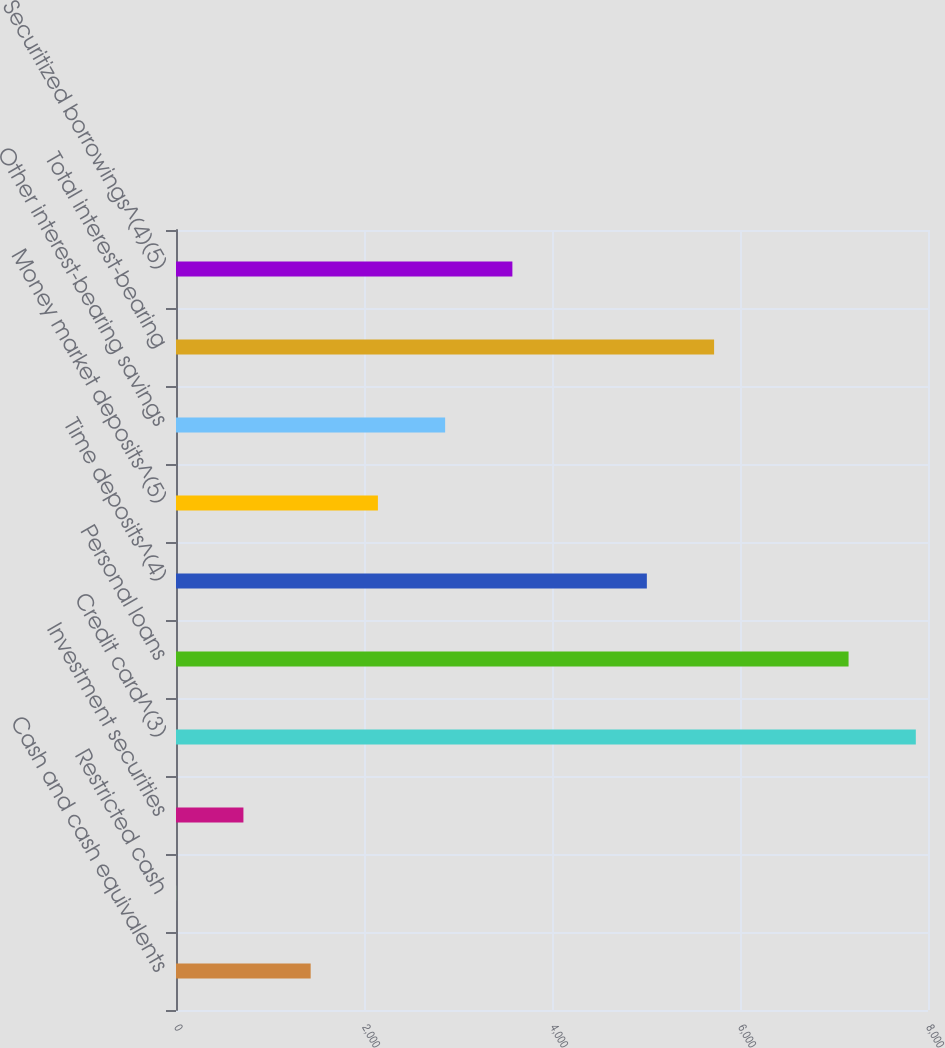Convert chart. <chart><loc_0><loc_0><loc_500><loc_500><bar_chart><fcel>Cash and cash equivalents<fcel>Restricted cash<fcel>Investment securities<fcel>Credit card^(3)<fcel>Personal loans<fcel>Time deposits^(4)<fcel>Money market deposits^(5)<fcel>Other interest-bearing savings<fcel>Total interest-bearing<fcel>Securitized borrowings^(4)(5)<nl><fcel>1432.6<fcel>2<fcel>717.3<fcel>7870.3<fcel>7155<fcel>5009.1<fcel>2147.9<fcel>2863.2<fcel>5724.4<fcel>3578.5<nl></chart> 